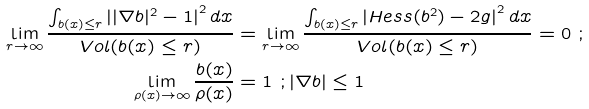Convert formula to latex. <formula><loc_0><loc_0><loc_500><loc_500>\lim _ { r \rightarrow \infty } \frac { \int _ { b ( x ) \leq r } \left | | \nabla b | ^ { 2 } - 1 \right | ^ { 2 } d x } { V o l ( b ( x ) \leq r ) } & = \lim _ { r \rightarrow \infty } \frac { \int _ { b ( x ) \leq r } \left | H e s s ( b ^ { 2 } ) - 2 g \right | ^ { 2 } d x } { V o l ( b ( x ) \leq r ) } = 0 \ ; \\ \lim _ { \rho ( x ) \rightarrow \infty } \frac { b ( x ) } { \rho ( x ) } & = 1 \ ; | \nabla b | \leq 1</formula> 